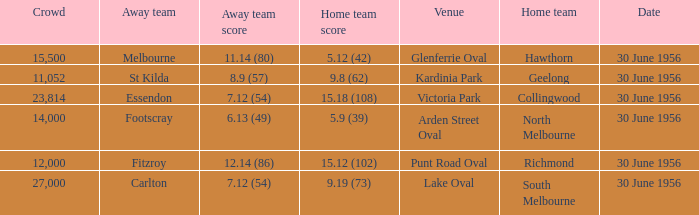What is the home team at Victoria Park with an Away team score of 7.12 (54) and more than 12,000 people? Collingwood. 